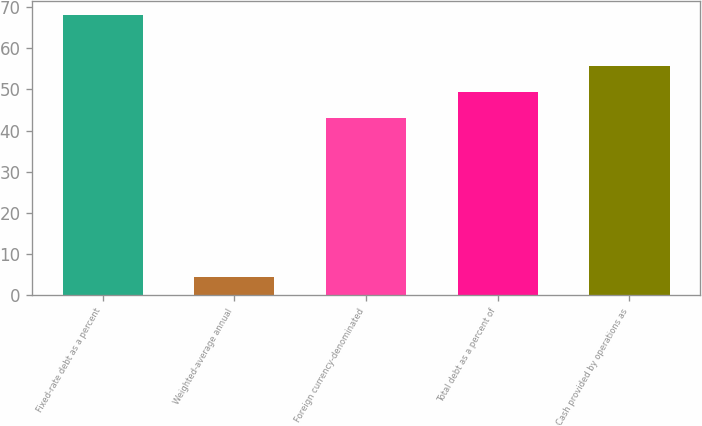<chart> <loc_0><loc_0><loc_500><loc_500><bar_chart><fcel>Fixed-rate debt as a percent<fcel>Weighted-average annual<fcel>Foreign currency-denominated<fcel>Total debt as a percent of<fcel>Cash provided by operations as<nl><fcel>68<fcel>4.5<fcel>43<fcel>49.35<fcel>55.7<nl></chart> 